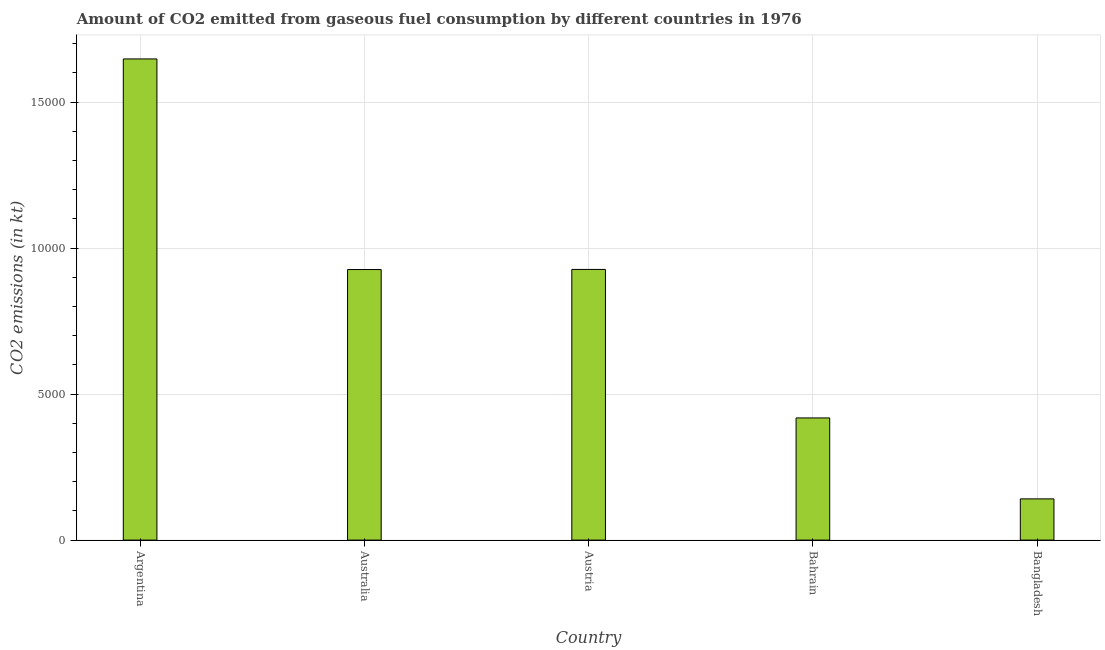What is the title of the graph?
Offer a terse response. Amount of CO2 emitted from gaseous fuel consumption by different countries in 1976. What is the label or title of the X-axis?
Provide a succinct answer. Country. What is the label or title of the Y-axis?
Ensure brevity in your answer.  CO2 emissions (in kt). What is the co2 emissions from gaseous fuel consumption in Bangladesh?
Provide a short and direct response. 1411.8. Across all countries, what is the maximum co2 emissions from gaseous fuel consumption?
Your response must be concise. 1.65e+04. Across all countries, what is the minimum co2 emissions from gaseous fuel consumption?
Ensure brevity in your answer.  1411.8. In which country was the co2 emissions from gaseous fuel consumption maximum?
Offer a very short reply. Argentina. In which country was the co2 emissions from gaseous fuel consumption minimum?
Your answer should be compact. Bangladesh. What is the sum of the co2 emissions from gaseous fuel consumption?
Keep it short and to the point. 4.06e+04. What is the difference between the co2 emissions from gaseous fuel consumption in Australia and Bahrain?
Your response must be concise. 5082.46. What is the average co2 emissions from gaseous fuel consumption per country?
Provide a succinct answer. 8122.4. What is the median co2 emissions from gaseous fuel consumption?
Give a very brief answer. 9266.51. What is the ratio of the co2 emissions from gaseous fuel consumption in Austria to that in Bahrain?
Your answer should be compact. 2.22. Is the co2 emissions from gaseous fuel consumption in Australia less than that in Austria?
Offer a terse response. Yes. Is the difference between the co2 emissions from gaseous fuel consumption in Argentina and Australia greater than the difference between any two countries?
Keep it short and to the point. No. What is the difference between the highest and the second highest co2 emissions from gaseous fuel consumption?
Your answer should be compact. 7209.32. What is the difference between the highest and the lowest co2 emissions from gaseous fuel consumption?
Ensure brevity in your answer.  1.51e+04. Are all the bars in the graph horizontal?
Your answer should be very brief. No. How many countries are there in the graph?
Your answer should be compact. 5. What is the CO2 emissions (in kt) in Argentina?
Give a very brief answer. 1.65e+04. What is the CO2 emissions (in kt) in Australia?
Keep it short and to the point. 9266.51. What is the CO2 emissions (in kt) of Austria?
Make the answer very short. 9270.18. What is the CO2 emissions (in kt) of Bahrain?
Make the answer very short. 4184.05. What is the CO2 emissions (in kt) of Bangladesh?
Your response must be concise. 1411.8. What is the difference between the CO2 emissions (in kt) in Argentina and Australia?
Your answer should be compact. 7212.99. What is the difference between the CO2 emissions (in kt) in Argentina and Austria?
Make the answer very short. 7209.32. What is the difference between the CO2 emissions (in kt) in Argentina and Bahrain?
Ensure brevity in your answer.  1.23e+04. What is the difference between the CO2 emissions (in kt) in Argentina and Bangladesh?
Your answer should be very brief. 1.51e+04. What is the difference between the CO2 emissions (in kt) in Australia and Austria?
Make the answer very short. -3.67. What is the difference between the CO2 emissions (in kt) in Australia and Bahrain?
Provide a succinct answer. 5082.46. What is the difference between the CO2 emissions (in kt) in Australia and Bangladesh?
Make the answer very short. 7854.71. What is the difference between the CO2 emissions (in kt) in Austria and Bahrain?
Your answer should be very brief. 5086.13. What is the difference between the CO2 emissions (in kt) in Austria and Bangladesh?
Provide a succinct answer. 7858.38. What is the difference between the CO2 emissions (in kt) in Bahrain and Bangladesh?
Provide a short and direct response. 2772.25. What is the ratio of the CO2 emissions (in kt) in Argentina to that in Australia?
Provide a succinct answer. 1.78. What is the ratio of the CO2 emissions (in kt) in Argentina to that in Austria?
Keep it short and to the point. 1.78. What is the ratio of the CO2 emissions (in kt) in Argentina to that in Bahrain?
Provide a short and direct response. 3.94. What is the ratio of the CO2 emissions (in kt) in Argentina to that in Bangladesh?
Your response must be concise. 11.67. What is the ratio of the CO2 emissions (in kt) in Australia to that in Bahrain?
Ensure brevity in your answer.  2.21. What is the ratio of the CO2 emissions (in kt) in Australia to that in Bangladesh?
Provide a short and direct response. 6.56. What is the ratio of the CO2 emissions (in kt) in Austria to that in Bahrain?
Keep it short and to the point. 2.22. What is the ratio of the CO2 emissions (in kt) in Austria to that in Bangladesh?
Your answer should be very brief. 6.57. What is the ratio of the CO2 emissions (in kt) in Bahrain to that in Bangladesh?
Your answer should be compact. 2.96. 